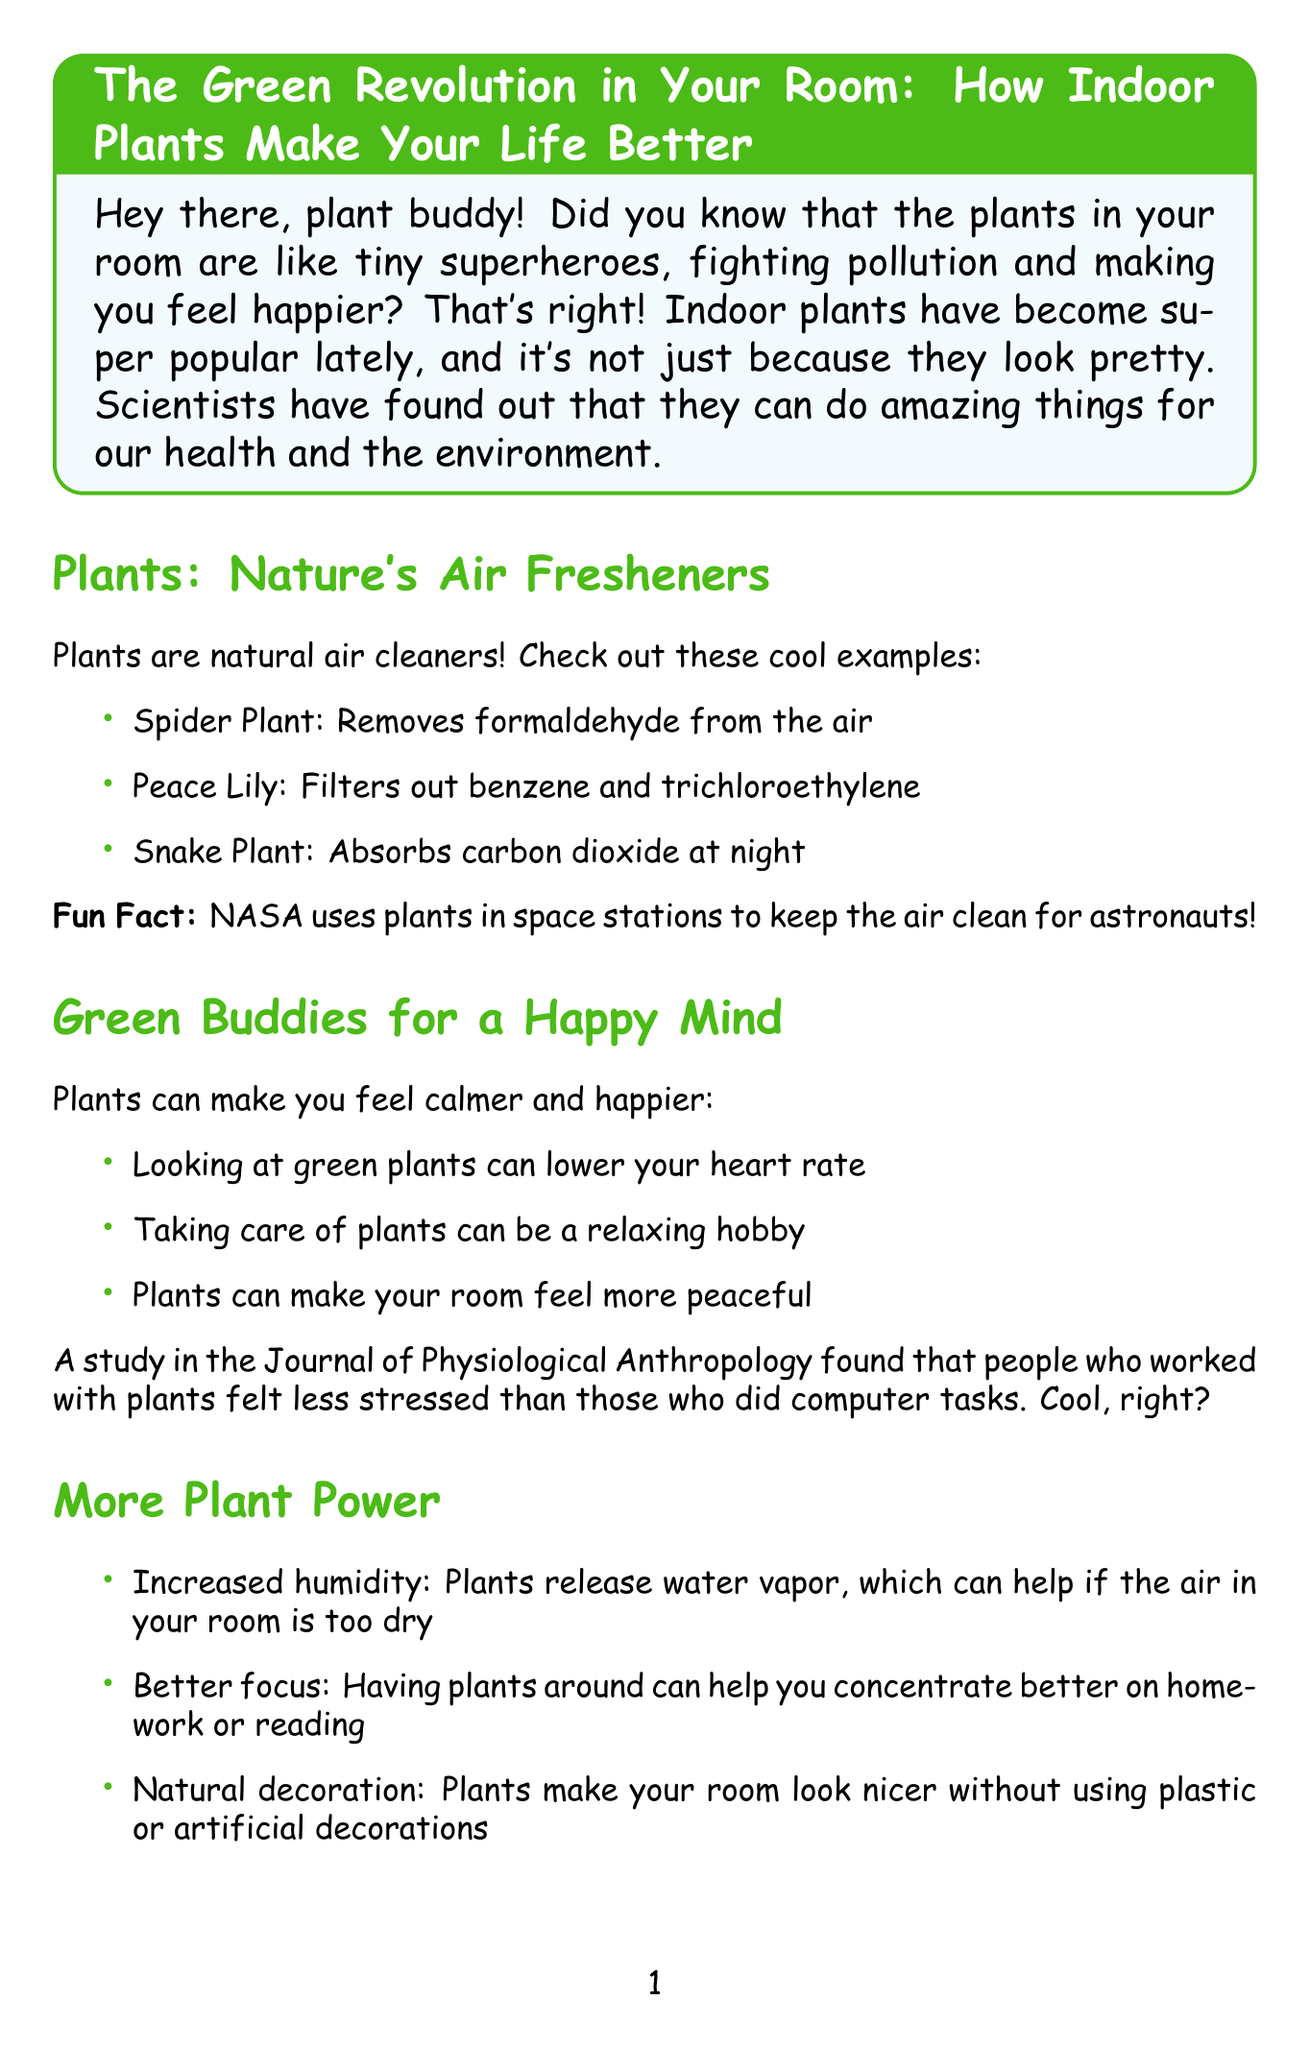What is the title of the report? The title is stated at the beginning of the document under the main heading.
Answer: The Green Revolution in Your Room: How Indoor Plants Make Your Life Better What is one benefit of the Spider Plant? The benefit of the Spider Plant is listed in the air purification section, specifically mentioning what it removes from the air.
Answer: Removes formaldehyde from the air Which journal published the study about plants and stress? The document provides the source of the study that found working with plants reduces stress.
Answer: Journal of Physiological Anthropology How many easy plants for beginners are mentioned? The document lists easy plants for beginners in a specific section, and counting them gives the total number.
Answer: Three What can plants release that helps increase humidity? This information is provided in the other benefits section, explaining how plants contribute to room conditions.
Answer: Water vapor What is a reason why plants can make you feel calmer? The reasons are listed in the stress reduction section, stating one specific effect on heart rate.
Answer: Looking at green plants can lower your heart rate Who is the author of the book mentioned in additional resources? The name of the author is provided next to the book title in the additional resources section.
Answer: Lisa Eldred Steinkopf 